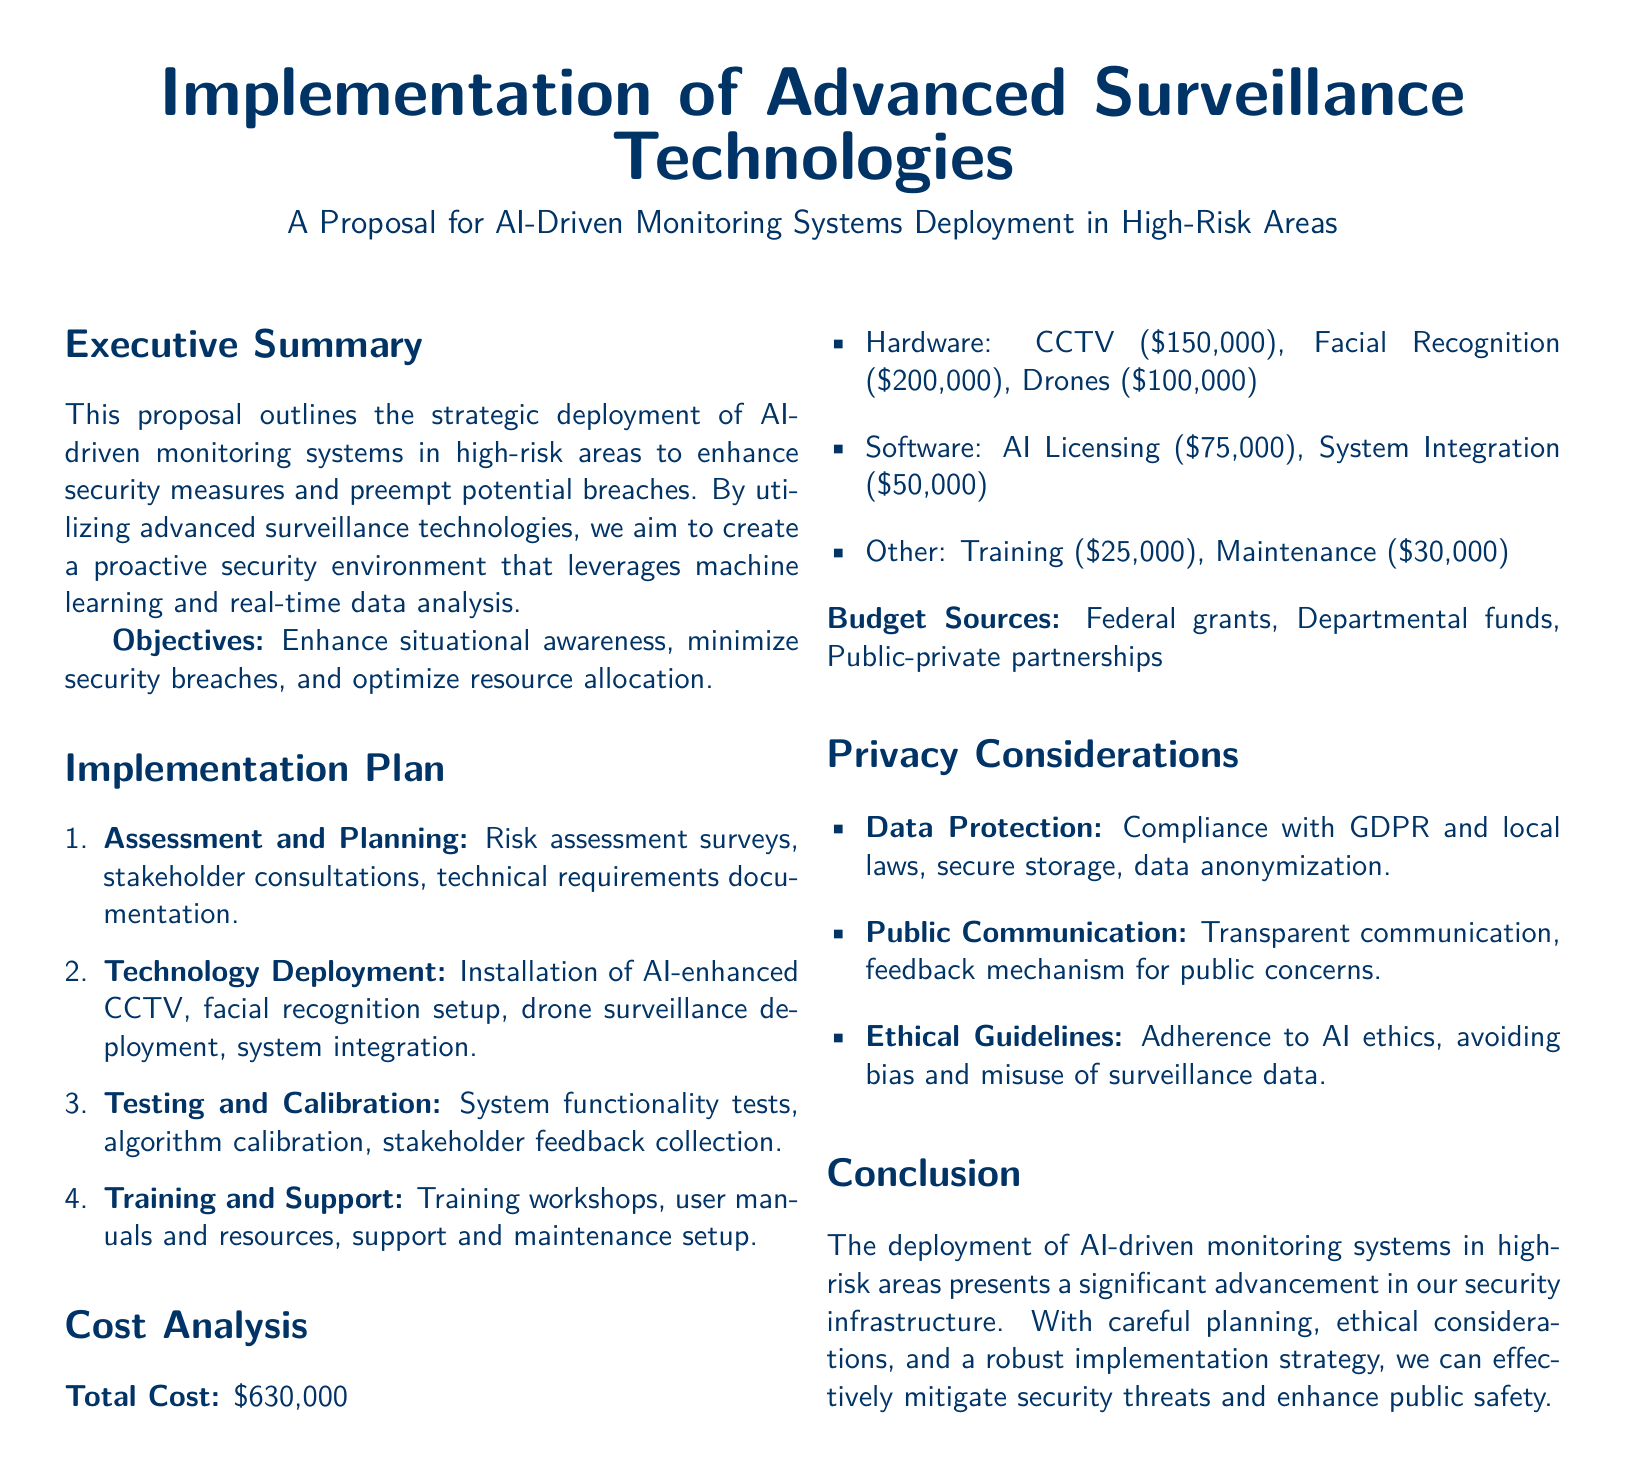What is the total cost of the surveillance project? The total cost is mentioned in the Cost Analysis section of the document, which sums up all expenses.
Answer: $630,000 What technologies are included in the technology deployment? The document lists the technologies as AI-enhanced CCTV, facial recognition, and drone surveillance.
Answer: AI-enhanced CCTV, facial recognition, drone surveillance How much is allocated for hardware costs? The hardware costs are detailed in the Cost Analysis section itemization for the respective technologies.
Answer: $450,000 What compliance standard is mentioned for data protection? The privacy considerations section mentions compliance with specific data protection regulations.
Answer: GDPR What is the budget source mentioned for funding the project? The document lists several funding sources in the Cost Analysis section.
Answer: Federal grants What is the purpose of the training workshops? The purpose is to provide users with resources and support related to the new technologies being deployed.
Answer: User training What is the aim of the deployment according to the executive summary? The executive summary outlines the primary objectives behind deploying the surveillance technologies.
Answer: Enhance security measures What type of areas will the AI-driven monitoring systems be deployed in? The focus is on high-risk areas as defined in the proposal.
Answer: High-risk areas What ethical aspect is included in the privacy considerations? The document emphasizes the need for adherence to ethical standards during the deployment of AI technologies.
Answer: Adherence to AI ethics 